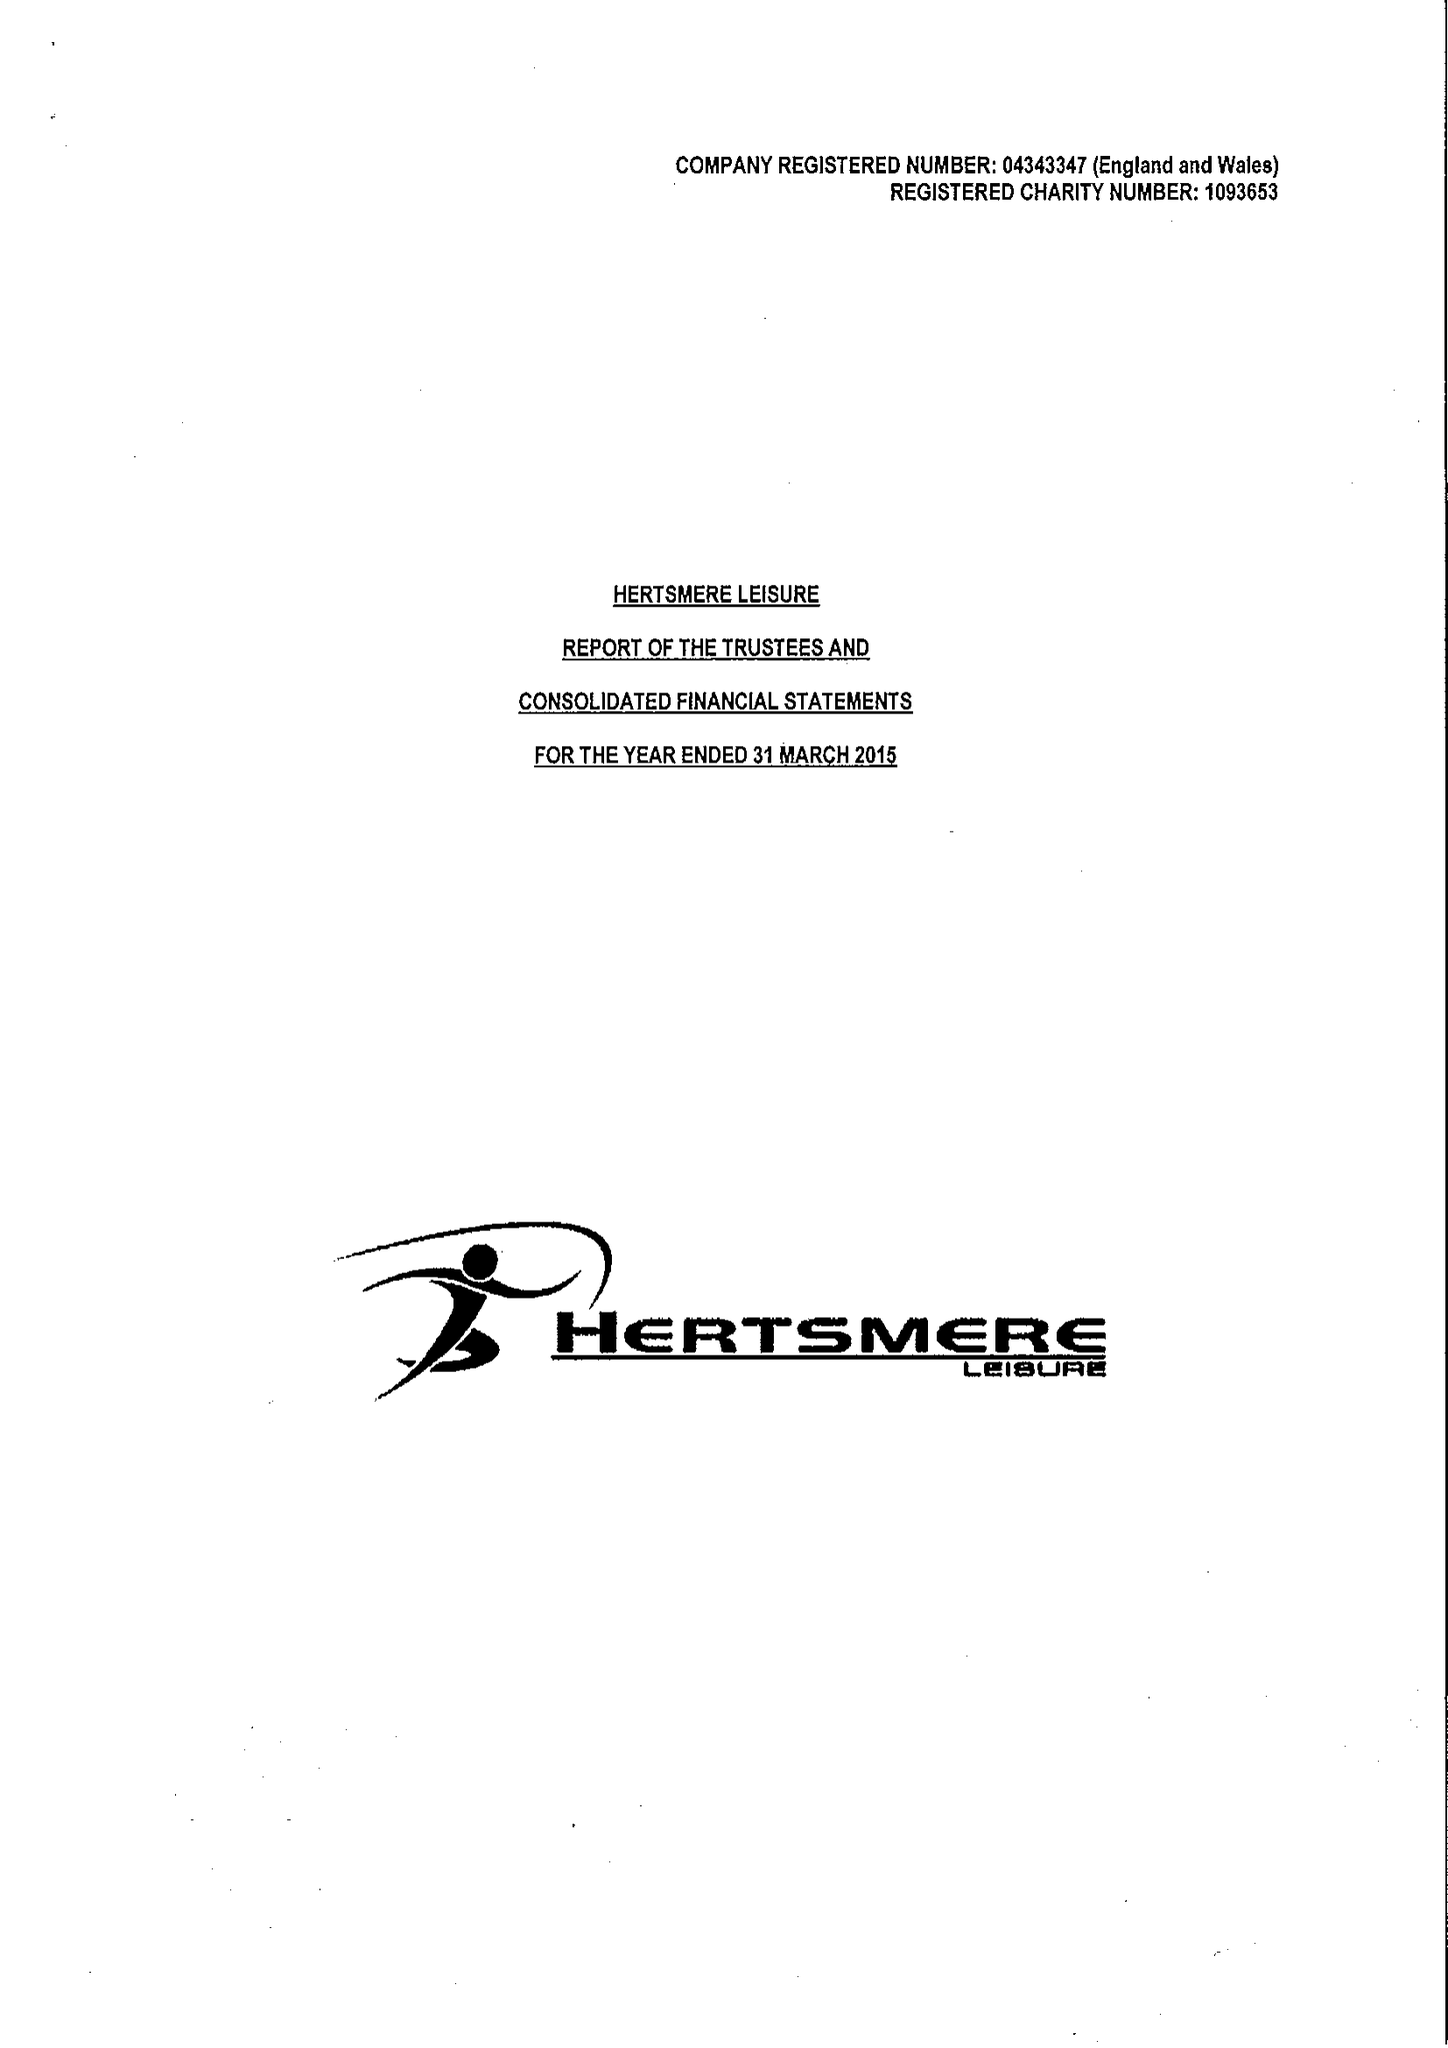What is the value for the address__street_line?
Answer the question using a single word or phrase. ELSTREE WAY 